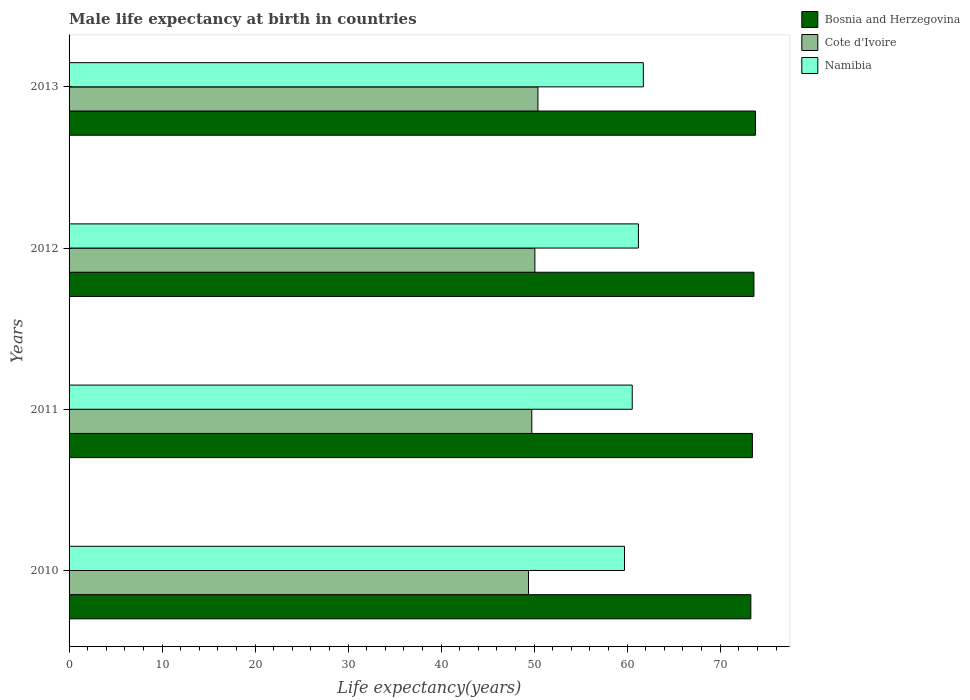Are the number of bars on each tick of the Y-axis equal?
Offer a very short reply. Yes. How many bars are there on the 4th tick from the top?
Offer a terse response. 3. How many bars are there on the 1st tick from the bottom?
Your answer should be very brief. 3. In how many cases, is the number of bars for a given year not equal to the number of legend labels?
Your answer should be very brief. 0. What is the male life expectancy at birth in Namibia in 2011?
Provide a succinct answer. 60.54. Across all years, what is the maximum male life expectancy at birth in Bosnia and Herzegovina?
Your answer should be compact. 73.79. Across all years, what is the minimum male life expectancy at birth in Bosnia and Herzegovina?
Your answer should be very brief. 73.3. What is the total male life expectancy at birth in Namibia in the graph?
Offer a terse response. 243.2. What is the difference between the male life expectancy at birth in Namibia in 2011 and that in 2013?
Offer a very short reply. -1.2. What is the difference between the male life expectancy at birth in Namibia in 2011 and the male life expectancy at birth in Cote d'Ivoire in 2012?
Your response must be concise. 10.47. What is the average male life expectancy at birth in Bosnia and Herzegovina per year?
Make the answer very short. 73.54. In the year 2011, what is the difference between the male life expectancy at birth in Namibia and male life expectancy at birth in Cote d'Ivoire?
Keep it short and to the point. 10.8. What is the ratio of the male life expectancy at birth in Cote d'Ivoire in 2010 to that in 2011?
Make the answer very short. 0.99. Is the male life expectancy at birth in Namibia in 2010 less than that in 2011?
Offer a very short reply. Yes. Is the difference between the male life expectancy at birth in Namibia in 2012 and 2013 greater than the difference between the male life expectancy at birth in Cote d'Ivoire in 2012 and 2013?
Ensure brevity in your answer.  No. What is the difference between the highest and the second highest male life expectancy at birth in Cote d'Ivoire?
Offer a very short reply. 0.33. What is the difference between the highest and the lowest male life expectancy at birth in Cote d'Ivoire?
Make the answer very short. 1.02. What does the 2nd bar from the top in 2010 represents?
Your answer should be compact. Cote d'Ivoire. What does the 1st bar from the bottom in 2012 represents?
Make the answer very short. Bosnia and Herzegovina. Is it the case that in every year, the sum of the male life expectancy at birth in Bosnia and Herzegovina and male life expectancy at birth in Cote d'Ivoire is greater than the male life expectancy at birth in Namibia?
Offer a terse response. Yes. How many bars are there?
Ensure brevity in your answer.  12. How many years are there in the graph?
Offer a terse response. 4. Are the values on the major ticks of X-axis written in scientific E-notation?
Your answer should be compact. No. Does the graph contain grids?
Make the answer very short. No. Where does the legend appear in the graph?
Provide a short and direct response. Top right. How are the legend labels stacked?
Your answer should be compact. Vertical. What is the title of the graph?
Offer a terse response. Male life expectancy at birth in countries. What is the label or title of the X-axis?
Provide a short and direct response. Life expectancy(years). What is the label or title of the Y-axis?
Offer a very short reply. Years. What is the Life expectancy(years) of Bosnia and Herzegovina in 2010?
Your response must be concise. 73.3. What is the Life expectancy(years) of Cote d'Ivoire in 2010?
Make the answer very short. 49.39. What is the Life expectancy(years) in Namibia in 2010?
Your answer should be very brief. 59.71. What is the Life expectancy(years) of Bosnia and Herzegovina in 2011?
Your answer should be very brief. 73.46. What is the Life expectancy(years) in Cote d'Ivoire in 2011?
Offer a terse response. 49.75. What is the Life expectancy(years) of Namibia in 2011?
Make the answer very short. 60.54. What is the Life expectancy(years) in Bosnia and Herzegovina in 2012?
Your answer should be very brief. 73.63. What is the Life expectancy(years) of Cote d'Ivoire in 2012?
Offer a terse response. 50.08. What is the Life expectancy(years) in Namibia in 2012?
Keep it short and to the point. 61.21. What is the Life expectancy(years) of Bosnia and Herzegovina in 2013?
Your response must be concise. 73.79. What is the Life expectancy(years) of Cote d'Ivoire in 2013?
Give a very brief answer. 50.41. What is the Life expectancy(years) in Namibia in 2013?
Give a very brief answer. 61.74. Across all years, what is the maximum Life expectancy(years) of Bosnia and Herzegovina?
Provide a short and direct response. 73.79. Across all years, what is the maximum Life expectancy(years) in Cote d'Ivoire?
Give a very brief answer. 50.41. Across all years, what is the maximum Life expectancy(years) of Namibia?
Your response must be concise. 61.74. Across all years, what is the minimum Life expectancy(years) in Bosnia and Herzegovina?
Offer a terse response. 73.3. Across all years, what is the minimum Life expectancy(years) of Cote d'Ivoire?
Your answer should be compact. 49.39. Across all years, what is the minimum Life expectancy(years) of Namibia?
Your response must be concise. 59.71. What is the total Life expectancy(years) of Bosnia and Herzegovina in the graph?
Provide a short and direct response. 294.18. What is the total Life expectancy(years) in Cote d'Ivoire in the graph?
Give a very brief answer. 199.62. What is the total Life expectancy(years) of Namibia in the graph?
Ensure brevity in your answer.  243.2. What is the difference between the Life expectancy(years) in Bosnia and Herzegovina in 2010 and that in 2011?
Make the answer very short. -0.17. What is the difference between the Life expectancy(years) of Cote d'Ivoire in 2010 and that in 2011?
Offer a very short reply. -0.36. What is the difference between the Life expectancy(years) in Namibia in 2010 and that in 2011?
Keep it short and to the point. -0.83. What is the difference between the Life expectancy(years) of Bosnia and Herzegovina in 2010 and that in 2012?
Your answer should be compact. -0.33. What is the difference between the Life expectancy(years) in Cote d'Ivoire in 2010 and that in 2012?
Provide a short and direct response. -0.69. What is the difference between the Life expectancy(years) of Namibia in 2010 and that in 2012?
Ensure brevity in your answer.  -1.5. What is the difference between the Life expectancy(years) in Bosnia and Herzegovina in 2010 and that in 2013?
Ensure brevity in your answer.  -0.5. What is the difference between the Life expectancy(years) of Cote d'Ivoire in 2010 and that in 2013?
Offer a very short reply. -1.02. What is the difference between the Life expectancy(years) of Namibia in 2010 and that in 2013?
Provide a succinct answer. -2.03. What is the difference between the Life expectancy(years) of Bosnia and Herzegovina in 2011 and that in 2012?
Make the answer very short. -0.17. What is the difference between the Life expectancy(years) in Cote d'Ivoire in 2011 and that in 2012?
Offer a very short reply. -0.33. What is the difference between the Life expectancy(years) in Namibia in 2011 and that in 2012?
Your answer should be very brief. -0.66. What is the difference between the Life expectancy(years) of Bosnia and Herzegovina in 2011 and that in 2013?
Offer a terse response. -0.33. What is the difference between the Life expectancy(years) of Cote d'Ivoire in 2011 and that in 2013?
Your answer should be very brief. -0.66. What is the difference between the Life expectancy(years) of Namibia in 2011 and that in 2013?
Ensure brevity in your answer.  -1.2. What is the difference between the Life expectancy(years) of Bosnia and Herzegovina in 2012 and that in 2013?
Provide a succinct answer. -0.17. What is the difference between the Life expectancy(years) in Cote d'Ivoire in 2012 and that in 2013?
Your answer should be very brief. -0.33. What is the difference between the Life expectancy(years) of Namibia in 2012 and that in 2013?
Provide a succinct answer. -0.53. What is the difference between the Life expectancy(years) in Bosnia and Herzegovina in 2010 and the Life expectancy(years) in Cote d'Ivoire in 2011?
Your response must be concise. 23.55. What is the difference between the Life expectancy(years) in Bosnia and Herzegovina in 2010 and the Life expectancy(years) in Namibia in 2011?
Make the answer very short. 12.75. What is the difference between the Life expectancy(years) of Cote d'Ivoire in 2010 and the Life expectancy(years) of Namibia in 2011?
Your response must be concise. -11.15. What is the difference between the Life expectancy(years) in Bosnia and Herzegovina in 2010 and the Life expectancy(years) in Cote d'Ivoire in 2012?
Offer a very short reply. 23.22. What is the difference between the Life expectancy(years) in Bosnia and Herzegovina in 2010 and the Life expectancy(years) in Namibia in 2012?
Offer a very short reply. 12.09. What is the difference between the Life expectancy(years) in Cote d'Ivoire in 2010 and the Life expectancy(years) in Namibia in 2012?
Give a very brief answer. -11.82. What is the difference between the Life expectancy(years) in Bosnia and Herzegovina in 2010 and the Life expectancy(years) in Cote d'Ivoire in 2013?
Ensure brevity in your answer.  22.89. What is the difference between the Life expectancy(years) in Bosnia and Herzegovina in 2010 and the Life expectancy(years) in Namibia in 2013?
Make the answer very short. 11.56. What is the difference between the Life expectancy(years) in Cote d'Ivoire in 2010 and the Life expectancy(years) in Namibia in 2013?
Provide a short and direct response. -12.35. What is the difference between the Life expectancy(years) of Bosnia and Herzegovina in 2011 and the Life expectancy(years) of Cote d'Ivoire in 2012?
Keep it short and to the point. 23.38. What is the difference between the Life expectancy(years) of Bosnia and Herzegovina in 2011 and the Life expectancy(years) of Namibia in 2012?
Your answer should be very brief. 12.25. What is the difference between the Life expectancy(years) of Cote d'Ivoire in 2011 and the Life expectancy(years) of Namibia in 2012?
Keep it short and to the point. -11.46. What is the difference between the Life expectancy(years) of Bosnia and Herzegovina in 2011 and the Life expectancy(years) of Cote d'Ivoire in 2013?
Your answer should be very brief. 23.05. What is the difference between the Life expectancy(years) in Bosnia and Herzegovina in 2011 and the Life expectancy(years) in Namibia in 2013?
Provide a short and direct response. 11.72. What is the difference between the Life expectancy(years) of Cote d'Ivoire in 2011 and the Life expectancy(years) of Namibia in 2013?
Keep it short and to the point. -11.99. What is the difference between the Life expectancy(years) in Bosnia and Herzegovina in 2012 and the Life expectancy(years) in Cote d'Ivoire in 2013?
Your response must be concise. 23.22. What is the difference between the Life expectancy(years) in Bosnia and Herzegovina in 2012 and the Life expectancy(years) in Namibia in 2013?
Keep it short and to the point. 11.89. What is the difference between the Life expectancy(years) in Cote d'Ivoire in 2012 and the Life expectancy(years) in Namibia in 2013?
Provide a succinct answer. -11.66. What is the average Life expectancy(years) of Bosnia and Herzegovina per year?
Make the answer very short. 73.54. What is the average Life expectancy(years) of Cote d'Ivoire per year?
Ensure brevity in your answer.  49.91. What is the average Life expectancy(years) in Namibia per year?
Offer a very short reply. 60.8. In the year 2010, what is the difference between the Life expectancy(years) in Bosnia and Herzegovina and Life expectancy(years) in Cote d'Ivoire?
Offer a very short reply. 23.91. In the year 2010, what is the difference between the Life expectancy(years) in Bosnia and Herzegovina and Life expectancy(years) in Namibia?
Keep it short and to the point. 13.58. In the year 2010, what is the difference between the Life expectancy(years) in Cote d'Ivoire and Life expectancy(years) in Namibia?
Provide a succinct answer. -10.32. In the year 2011, what is the difference between the Life expectancy(years) in Bosnia and Herzegovina and Life expectancy(years) in Cote d'Ivoire?
Offer a very short reply. 23.71. In the year 2011, what is the difference between the Life expectancy(years) of Bosnia and Herzegovina and Life expectancy(years) of Namibia?
Your answer should be compact. 12.92. In the year 2011, what is the difference between the Life expectancy(years) of Cote d'Ivoire and Life expectancy(years) of Namibia?
Provide a short and direct response. -10.8. In the year 2012, what is the difference between the Life expectancy(years) in Bosnia and Herzegovina and Life expectancy(years) in Cote d'Ivoire?
Offer a very short reply. 23.55. In the year 2012, what is the difference between the Life expectancy(years) in Bosnia and Herzegovina and Life expectancy(years) in Namibia?
Give a very brief answer. 12.42. In the year 2012, what is the difference between the Life expectancy(years) of Cote d'Ivoire and Life expectancy(years) of Namibia?
Provide a short and direct response. -11.13. In the year 2013, what is the difference between the Life expectancy(years) in Bosnia and Herzegovina and Life expectancy(years) in Cote d'Ivoire?
Give a very brief answer. 23.39. In the year 2013, what is the difference between the Life expectancy(years) in Bosnia and Herzegovina and Life expectancy(years) in Namibia?
Make the answer very short. 12.05. In the year 2013, what is the difference between the Life expectancy(years) in Cote d'Ivoire and Life expectancy(years) in Namibia?
Your response must be concise. -11.33. What is the ratio of the Life expectancy(years) in Namibia in 2010 to that in 2011?
Your response must be concise. 0.99. What is the ratio of the Life expectancy(years) in Cote d'Ivoire in 2010 to that in 2012?
Offer a very short reply. 0.99. What is the ratio of the Life expectancy(years) of Namibia in 2010 to that in 2012?
Provide a succinct answer. 0.98. What is the ratio of the Life expectancy(years) of Cote d'Ivoire in 2010 to that in 2013?
Keep it short and to the point. 0.98. What is the ratio of the Life expectancy(years) of Namibia in 2010 to that in 2013?
Your answer should be very brief. 0.97. What is the ratio of the Life expectancy(years) of Cote d'Ivoire in 2011 to that in 2012?
Your response must be concise. 0.99. What is the ratio of the Life expectancy(years) in Bosnia and Herzegovina in 2011 to that in 2013?
Provide a short and direct response. 1. What is the ratio of the Life expectancy(years) in Cote d'Ivoire in 2011 to that in 2013?
Your answer should be very brief. 0.99. What is the ratio of the Life expectancy(years) of Namibia in 2011 to that in 2013?
Offer a terse response. 0.98. What is the ratio of the Life expectancy(years) in Bosnia and Herzegovina in 2012 to that in 2013?
Provide a succinct answer. 1. What is the ratio of the Life expectancy(years) of Cote d'Ivoire in 2012 to that in 2013?
Make the answer very short. 0.99. What is the ratio of the Life expectancy(years) in Namibia in 2012 to that in 2013?
Give a very brief answer. 0.99. What is the difference between the highest and the second highest Life expectancy(years) of Bosnia and Herzegovina?
Your answer should be compact. 0.17. What is the difference between the highest and the second highest Life expectancy(years) in Cote d'Ivoire?
Offer a very short reply. 0.33. What is the difference between the highest and the second highest Life expectancy(years) of Namibia?
Give a very brief answer. 0.53. What is the difference between the highest and the lowest Life expectancy(years) of Bosnia and Herzegovina?
Give a very brief answer. 0.5. What is the difference between the highest and the lowest Life expectancy(years) of Cote d'Ivoire?
Give a very brief answer. 1.02. What is the difference between the highest and the lowest Life expectancy(years) of Namibia?
Make the answer very short. 2.03. 